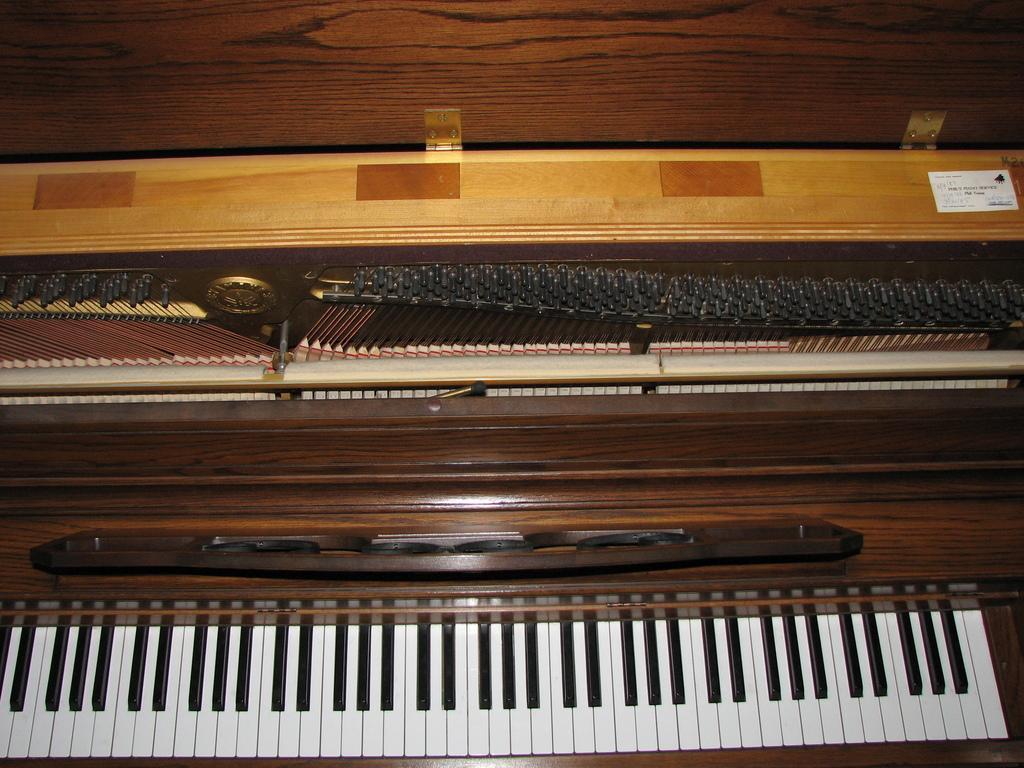Could you give a brief overview of what you see in this image? This is a musical instrument which is looking like a keyboard. This instrument has a box like, which has wooden box and placed in it. 